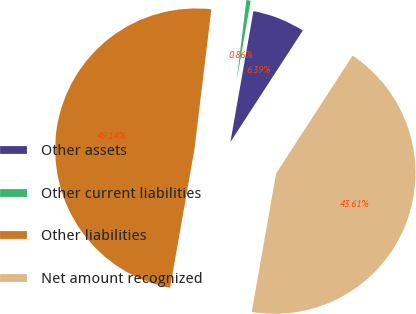Convert chart to OTSL. <chart><loc_0><loc_0><loc_500><loc_500><pie_chart><fcel>Other assets<fcel>Other current liabilities<fcel>Other liabilities<fcel>Net amount recognized<nl><fcel>6.39%<fcel>0.86%<fcel>49.14%<fcel>43.61%<nl></chart> 